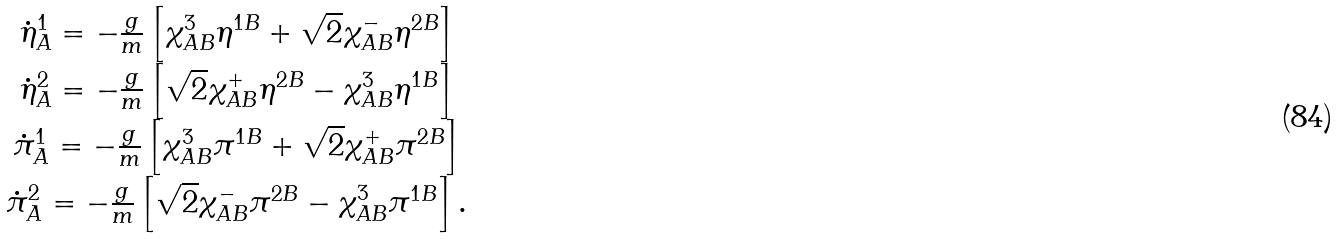<formula> <loc_0><loc_0><loc_500><loc_500>\begin{array} { c } \dot { \eta } ^ { 1 } _ { A } = - \frac { g } { m } \left [ \chi ^ { 3 } _ { A B } \eta ^ { 1 B } + \sqrt { 2 } \chi ^ { - } _ { A B } \eta ^ { 2 B } \right ] \\ \dot { \eta } ^ { 2 } _ { A } = - \frac { g } { m } \left [ \sqrt { 2 } \chi ^ { + } _ { A B } \eta ^ { 2 B } - \chi ^ { 3 } _ { A B } \eta ^ { 1 B } \right ] \\ \dot { \pi } ^ { 1 } _ { A } = - \frac { g } { m } \left [ \chi ^ { 3 } _ { A B } \pi ^ { 1 B } + \sqrt { 2 } \chi ^ { + } _ { A B } \pi ^ { 2 B } \right ] \\ \dot { \pi } ^ { 2 } _ { A } = - \frac { g } { m } \left [ \sqrt { 2 } \chi ^ { - } _ { A B } \pi ^ { 2 B } - \chi ^ { 3 } _ { A B } \pi ^ { 1 B } \right ] . \\ \end{array}</formula> 